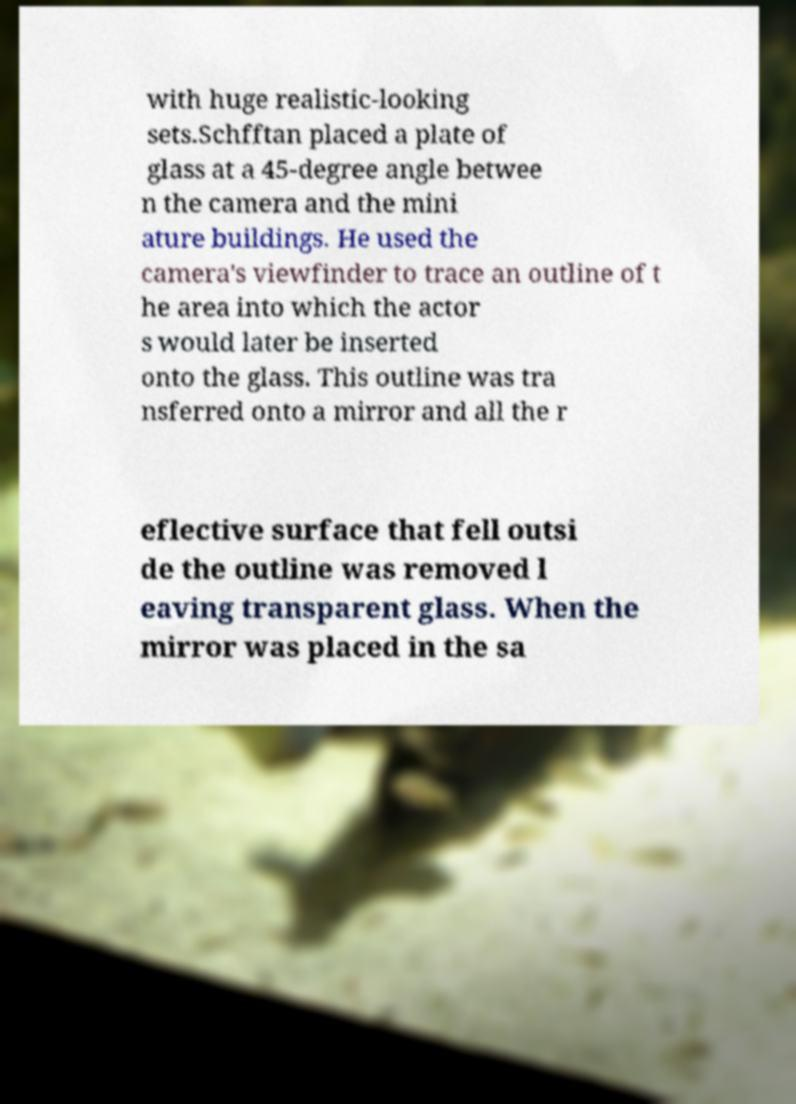Could you assist in decoding the text presented in this image and type it out clearly? with huge realistic-looking sets.Schfftan placed a plate of glass at a 45-degree angle betwee n the camera and the mini ature buildings. He used the camera's viewfinder to trace an outline of t he area into which the actor s would later be inserted onto the glass. This outline was tra nsferred onto a mirror and all the r eflective surface that fell outsi de the outline was removed l eaving transparent glass. When the mirror was placed in the sa 